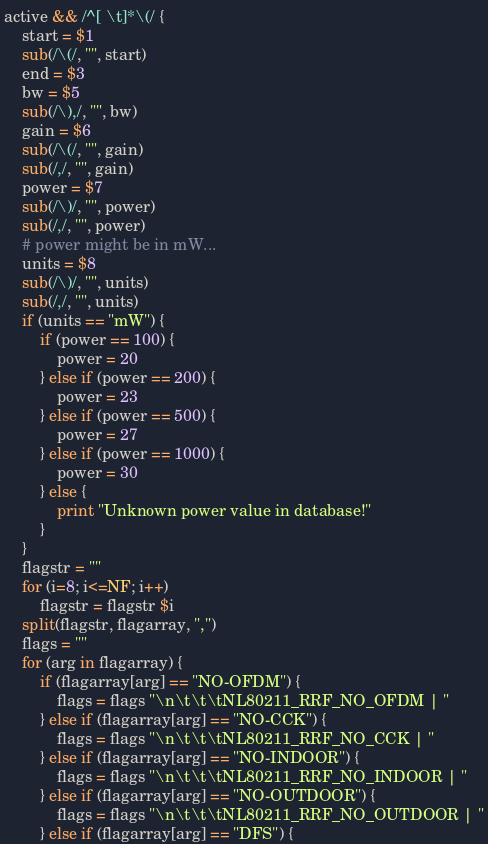Convert code to text. <code><loc_0><loc_0><loc_500><loc_500><_Awk_>active && /^[ \t]*\(/ {
	start = $1
	sub(/\(/, "", start)
	end = $3
	bw = $5
	sub(/\),/, "", bw)
	gain = $6
	sub(/\(/, "", gain)
	sub(/,/, "", gain)
	power = $7
	sub(/\)/, "", power)
	sub(/,/, "", power)
	# power might be in mW...
	units = $8
	sub(/\)/, "", units)
	sub(/,/, "", units)
	if (units == "mW") {
		if (power == 100) {
			power = 20
		} else if (power == 200) {
			power = 23
		} else if (power == 500) {
			power = 27
		} else if (power == 1000) {
			power = 30
		} else {
			print "Unknown power value in database!"
		}
	}
	flagstr = ""
	for (i=8; i<=NF; i++)
		flagstr = flagstr $i
	split(flagstr, flagarray, ",")
	flags = ""
	for (arg in flagarray) {
		if (flagarray[arg] == "NO-OFDM") {
			flags = flags "\n\t\t\tNL80211_RRF_NO_OFDM | "
		} else if (flagarray[arg] == "NO-CCK") {
			flags = flags "\n\t\t\tNL80211_RRF_NO_CCK | "
		} else if (flagarray[arg] == "NO-INDOOR") {
			flags = flags "\n\t\t\tNL80211_RRF_NO_INDOOR | "
		} else if (flagarray[arg] == "NO-OUTDOOR") {
			flags = flags "\n\t\t\tNL80211_RRF_NO_OUTDOOR | "
		} else if (flagarray[arg] == "DFS") {</code> 